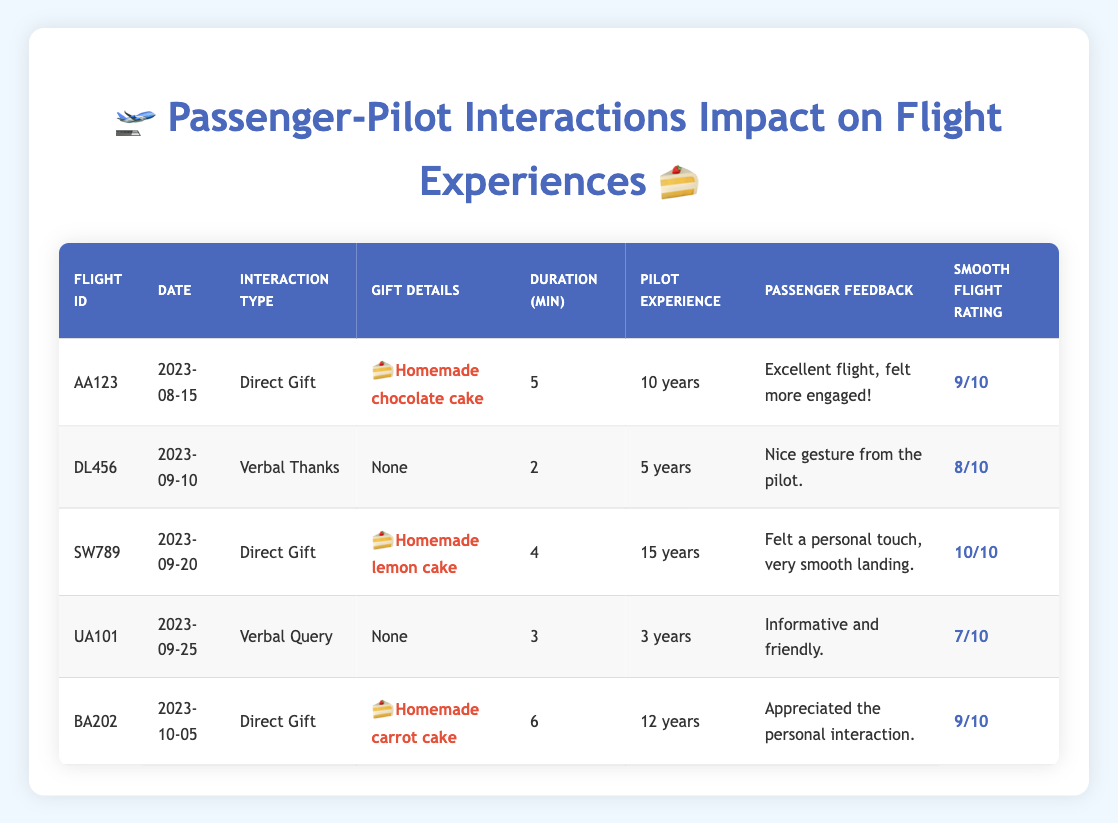What is the interaction type for flight AA123? According to the table, for flight ID AA123, the interaction type mentioned is "Direct Gift".
Answer: Direct Gift Which flight received a homemade lemon cake? Looking at the "Gift Details" column in the table, the flight SW789 is listed with the gift "homemade lemon cake".
Answer: SW789 How many minutes of interaction occurred during flight BA202? Referring to the "Duration (min)" column for flight BA202, it states that the interaction duration was 6 minutes.
Answer: 6 minutes What is the average smooth flight rating for flights with direct gifts? The smooth flight ratings for flights with direct gifts are 9, 10, and 9 (from flights AA123, SW789, and BA202 respectively). We sum these ratings (9 + 10 + 9 = 28) and divide by the number of flights with direct gifts (3): 28 / 3 = 9.33. This makes the average smooth flight rating for direct gift flights approximately 9.33.
Answer: 9.33 Is the pilot experience level for flight UA101 greater than 10 years? For flight UA101, the table shows a pilot experience level of "3 years". Since 3 is less than 10, the answer is no.
Answer: No Which flight had the highest smooth flight rating and what was the rating? In the table, SW789 had the highest smooth flight rating, which is 10 out of 10.
Answer: SW789, 10 What feedback did the passenger provide for flight DL456? The feedback provided for flight DL456 in the table states, "Nice gesture from the pilot."
Answer: Nice gesture from the pilot How many flights had interactions lasting more than 5 minutes? The table shows flights AA123 (5 minutes), SW789 (4 minutes), UA101 (3 minutes), and BA202 (6 minutes). Out of these, only BA202 with 6 minutes had an interaction lasting more than 5 minutes. Therefore, there was 1 flight.
Answer: 1 flight Did the passenger of flight UA101 express engagement during the interaction? The feedback from flight UA101 states, "Informative and friendly," which does not clearly indicate engagement as positively expressed as in other feedbacks. Therefore, we cannot consider it as a yes.
Answer: No 